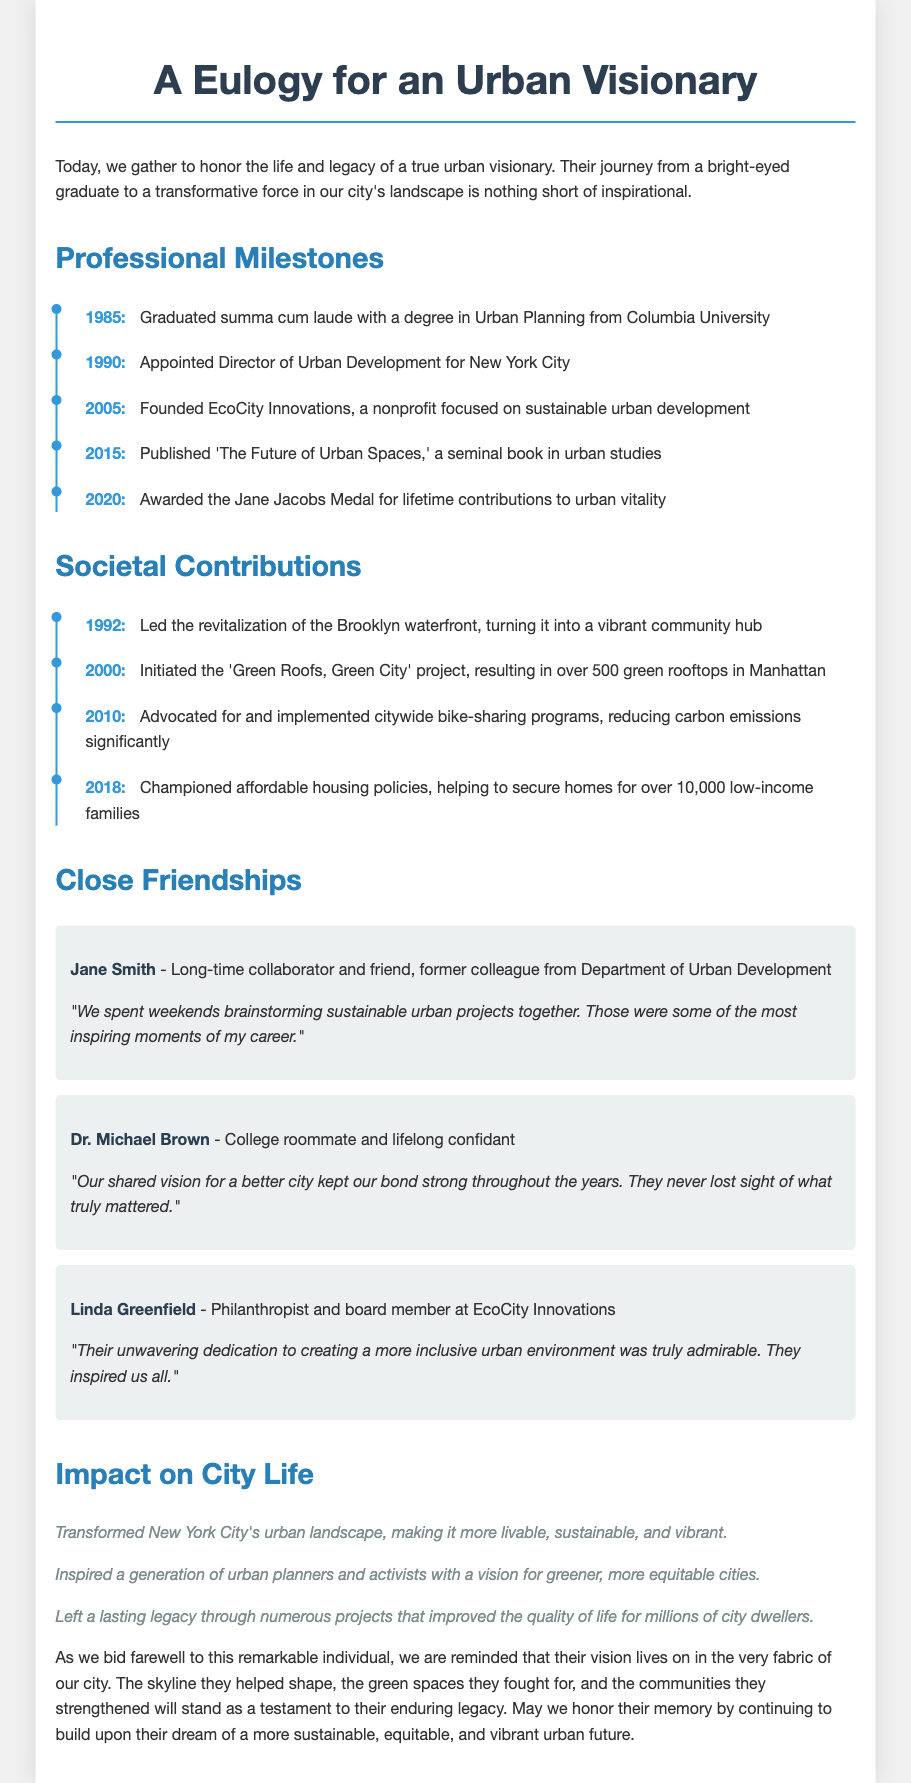what year did they graduate from Columbia University? The document states they graduated summa cum laude in 1985.
Answer: 1985 what is the name of the book they published in 2015? The document mentions they published 'The Future of Urban Spaces' in 2015.
Answer: The Future of Urban Spaces which project resulted in over 500 green rooftops in Manhattan? This initiative is identified as the 'Green Roofs, Green City' project initiated in 2000.
Answer: Green Roofs, Green City who awarded them the Jane Jacobs Medal? The Jane Jacobs Medal was awarded for lifetime contributions to urban vitality in 2020.
Answer: Jane Jacobs Medal what was their role in 1990? The document states they were appointed Director of Urban Development for New York City.
Answer: Director of Urban Development how many low-income families secured homes through their affordable housing policies? The text specifies that their policies helped secure homes for over 10,000 low-income families.
Answer: 10,000 which friend was a long-time collaborator from the Department of Urban Development? The document identifies Jane Smith as a long-time collaborator and friend.
Answer: Jane Smith what aspect of city life did their initiatives notably improve? The document highlights that their initiatives improved the quality of life for millions of city dwellers.
Answer: Quality of life what is the overarching theme of the eulogy? The eulogy reflects on transforming urban environments into more sustainable and equitable spaces.
Answer: Transforming urban environments 